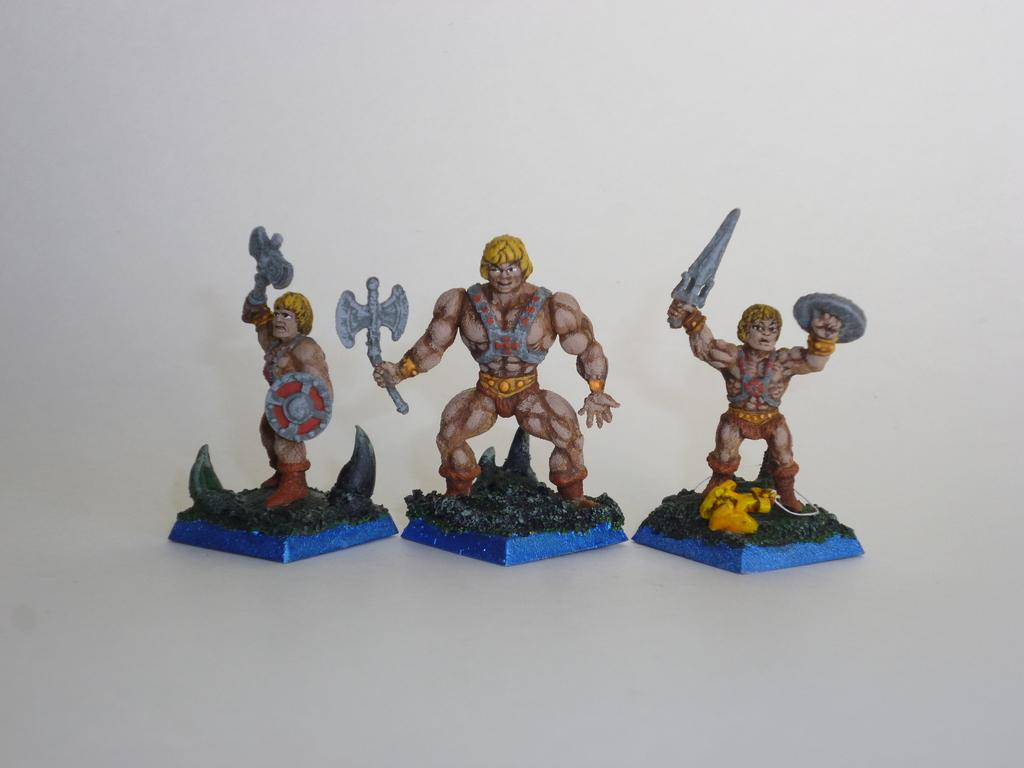What type of art is present in the image? There are sculptures in the image. Can you describe the sculptures in the image? Unfortunately, the provided facts do not include a description of the sculptures. Are the sculptures the only subject in the image? The provided facts only mention the presence of sculptures, so it is not clear if there are any other subjects in the image. How many cars are parked along the coast in the image? There are no cars or coast present in the image; it features sculptures. Who is in control of the sculptures in the image? The provided facts do not mention any individuals or entities in control of the sculptures. 